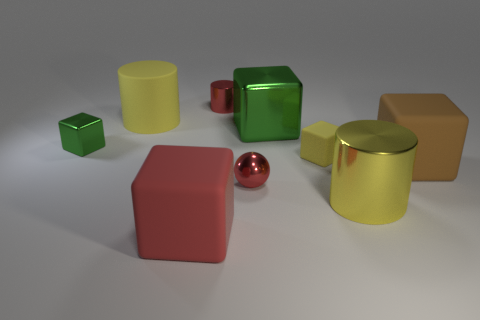What could be the possible materials of these objects? Based on their appearance, the objects could be made of a variety of materials. The yellow and brown cubes might be made of matte-finished plastic or painted wood. The green and gold cylinder objects have a high-gloss finish indicative of polished metal or a reflective plastic. The red block and the shiny small object seem to resemble metallic surfaces, suggesting they could be composed of a metal like steel or aluminum with a painted or anodized coating for color. 